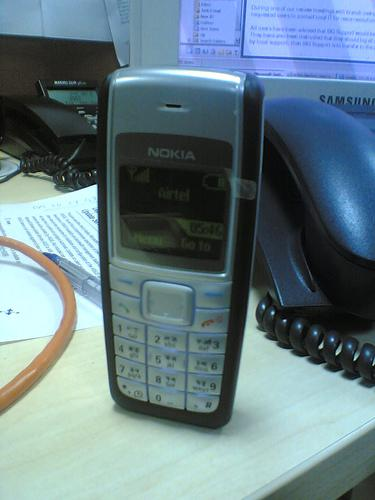Question: when was this picture taken?
Choices:
A. 5:46.
B. Yesterday night.
C. This morning.
D. Last Thursday.
Answer with the letter. Answer: A Question: how many cellphones are there?
Choices:
A. 1.
B. 3.
C. 4.
D. 5.
Answer with the letter. Answer: A Question: what is this a picture of?
Choices:
A. A cat.
B. Cell phone.
C. A dog.
D. A father.
Answer with the letter. Answer: B Question: why do you know when this picture was taken?
Choices:
A. 5:46 on the cellphone.
B. The time stamp.
C. The information screen.
D. It says on the back.
Answer with the letter. Answer: A 